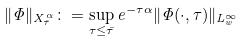Convert formula to latex. <formula><loc_0><loc_0><loc_500><loc_500>\| \Phi \| _ { X ^ { \alpha } _ { \bar { \tau } } } \colon = \sup _ { \tau \leq \bar { \tau } } e ^ { - \tau \alpha } \| \Phi ( \cdot , \tau ) \| _ { L ^ { \infty } _ { w } }</formula> 